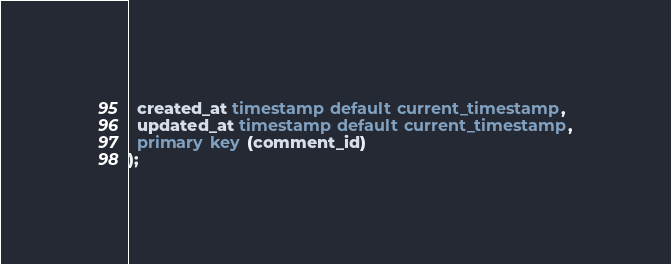Convert code to text. <code><loc_0><loc_0><loc_500><loc_500><_SQL_>  created_at timestamp default current_timestamp,
  updated_at timestamp default current_timestamp,
  primary key (comment_id)
);
</code> 